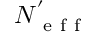Convert formula to latex. <formula><loc_0><loc_0><loc_500><loc_500>N _ { e f f } ^ { ^ { \prime } }</formula> 